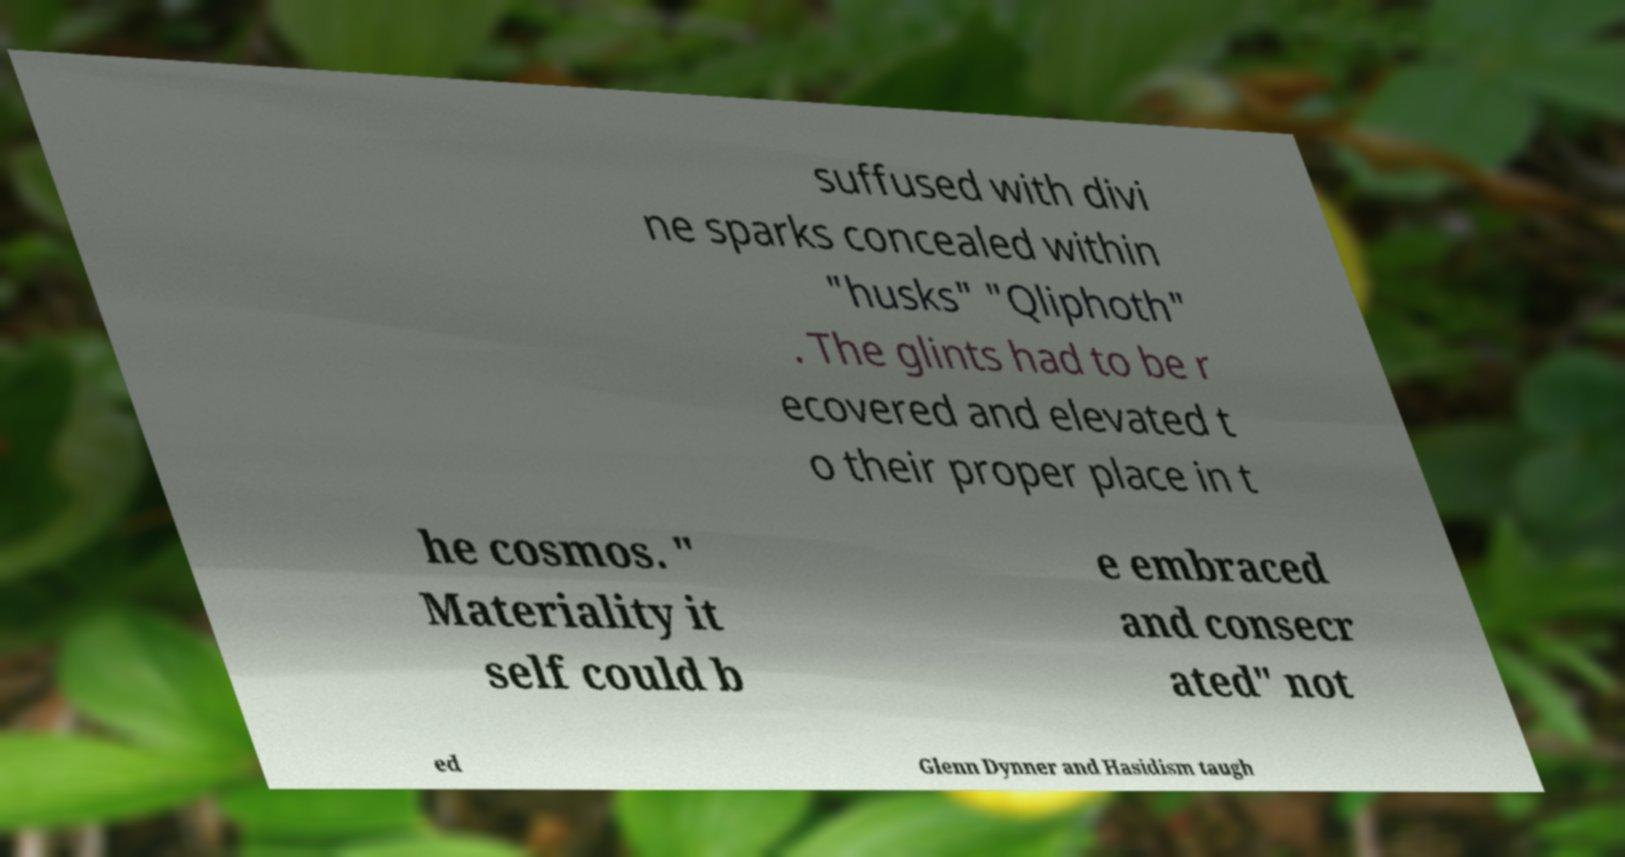Could you extract and type out the text from this image? suffused with divi ne sparks concealed within "husks" "Qliphoth" . The glints had to be r ecovered and elevated t o their proper place in t he cosmos. " Materiality it self could b e embraced and consecr ated" not ed Glenn Dynner and Hasidism taugh 